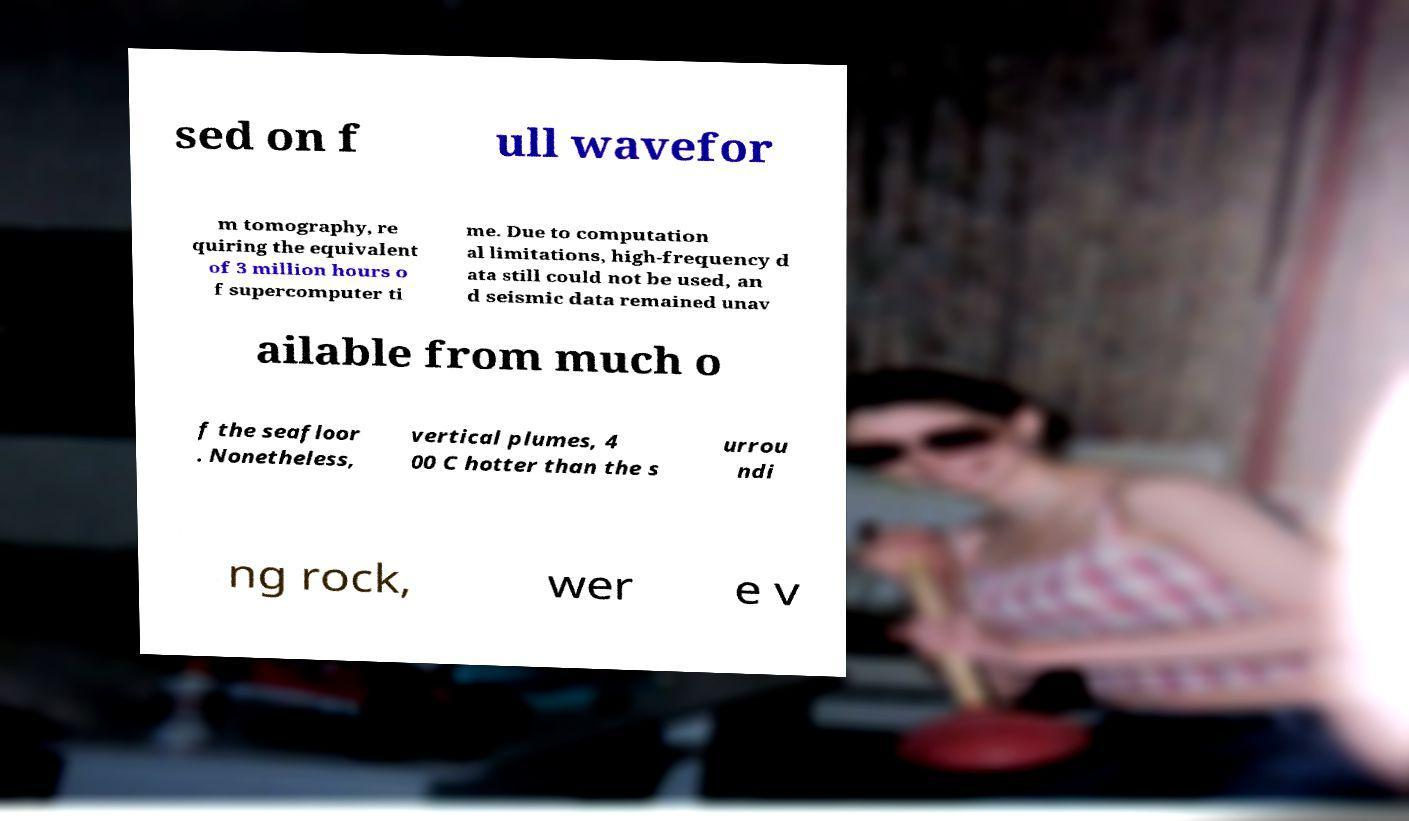Can you accurately transcribe the text from the provided image for me? sed on f ull wavefor m tomography, re quiring the equivalent of 3 million hours o f supercomputer ti me. Due to computation al limitations, high-frequency d ata still could not be used, an d seismic data remained unav ailable from much o f the seafloor . Nonetheless, vertical plumes, 4 00 C hotter than the s urrou ndi ng rock, wer e v 